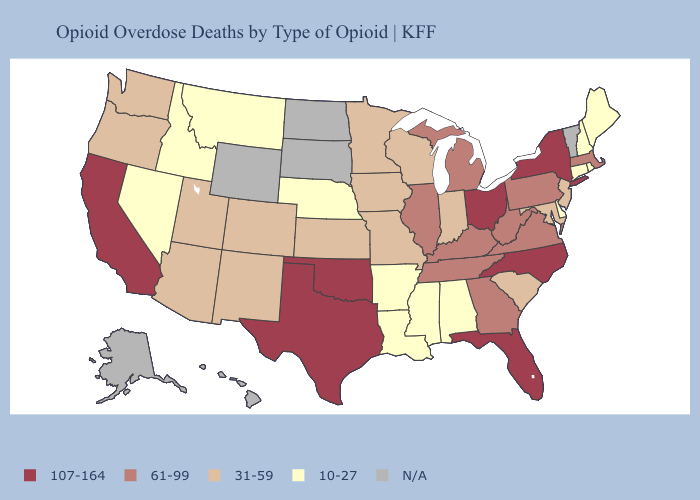What is the highest value in states that border Tennessee?
Write a very short answer. 107-164. Does Minnesota have the highest value in the USA?
Short answer required. No. Name the states that have a value in the range 31-59?
Be succinct. Arizona, Colorado, Indiana, Iowa, Kansas, Maryland, Minnesota, Missouri, New Jersey, New Mexico, Oregon, South Carolina, Utah, Washington, Wisconsin. What is the value of Hawaii?
Concise answer only. N/A. What is the value of New Hampshire?
Keep it brief. 10-27. What is the lowest value in states that border Colorado?
Give a very brief answer. 10-27. Among the states that border Ohio , which have the highest value?
Quick response, please. Kentucky, Michigan, Pennsylvania, West Virginia. What is the highest value in the Northeast ?
Quick response, please. 107-164. What is the lowest value in the Northeast?
Write a very short answer. 10-27. What is the value of Texas?
Answer briefly. 107-164. What is the value of Illinois?
Quick response, please. 61-99. Does the map have missing data?
Keep it brief. Yes. Does Arizona have the highest value in the West?
Short answer required. No. Does the map have missing data?
Answer briefly. Yes. 